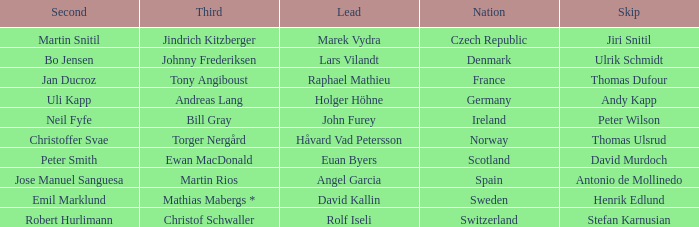When did France come in second? Jan Ducroz. 